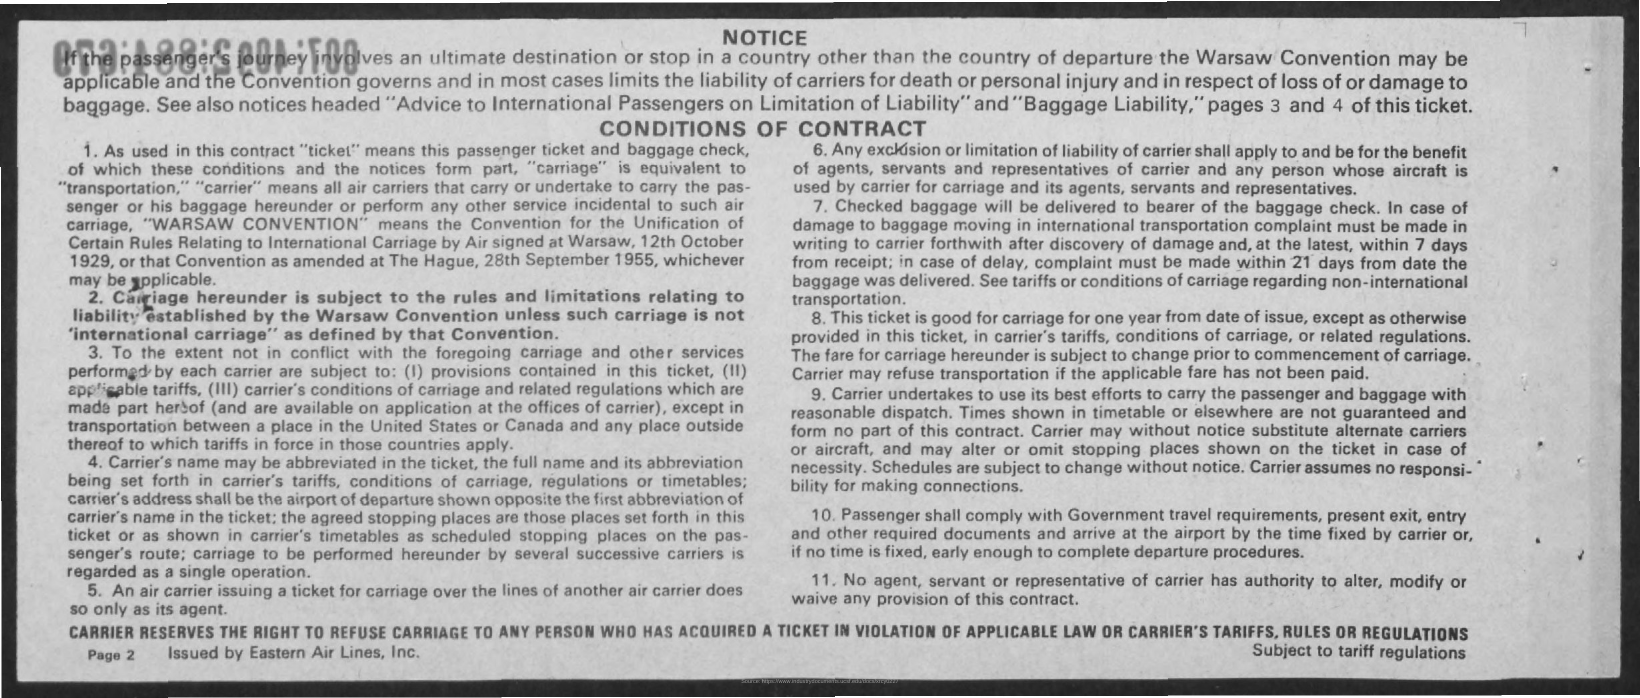List a handful of essential elements in this visual. The first title in the document is 'NOTICE..' The notice is issued by Eastern Air Lines, Inc. The page number is PAGE 2. The second title in the document is 'Conditions of Contract.' 